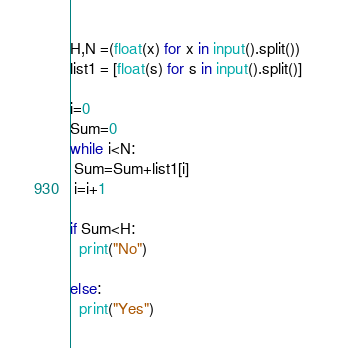Convert code to text. <code><loc_0><loc_0><loc_500><loc_500><_Python_>H,N =(float(x) for x in input().split())
list1 = [float(s) for s in input().split()] 

i=0
Sum=0
while i<N:
 Sum=Sum+list1[i]
 i=i+1

if Sum<H:
  print("No")

else:
  print("Yes")</code> 